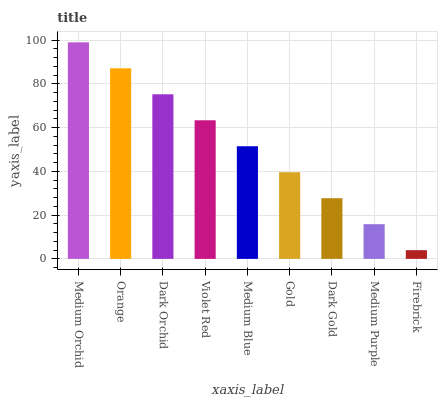Is Firebrick the minimum?
Answer yes or no. Yes. Is Medium Orchid the maximum?
Answer yes or no. Yes. Is Orange the minimum?
Answer yes or no. No. Is Orange the maximum?
Answer yes or no. No. Is Medium Orchid greater than Orange?
Answer yes or no. Yes. Is Orange less than Medium Orchid?
Answer yes or no. Yes. Is Orange greater than Medium Orchid?
Answer yes or no. No. Is Medium Orchid less than Orange?
Answer yes or no. No. Is Medium Blue the high median?
Answer yes or no. Yes. Is Medium Blue the low median?
Answer yes or no. Yes. Is Orange the high median?
Answer yes or no. No. Is Dark Orchid the low median?
Answer yes or no. No. 